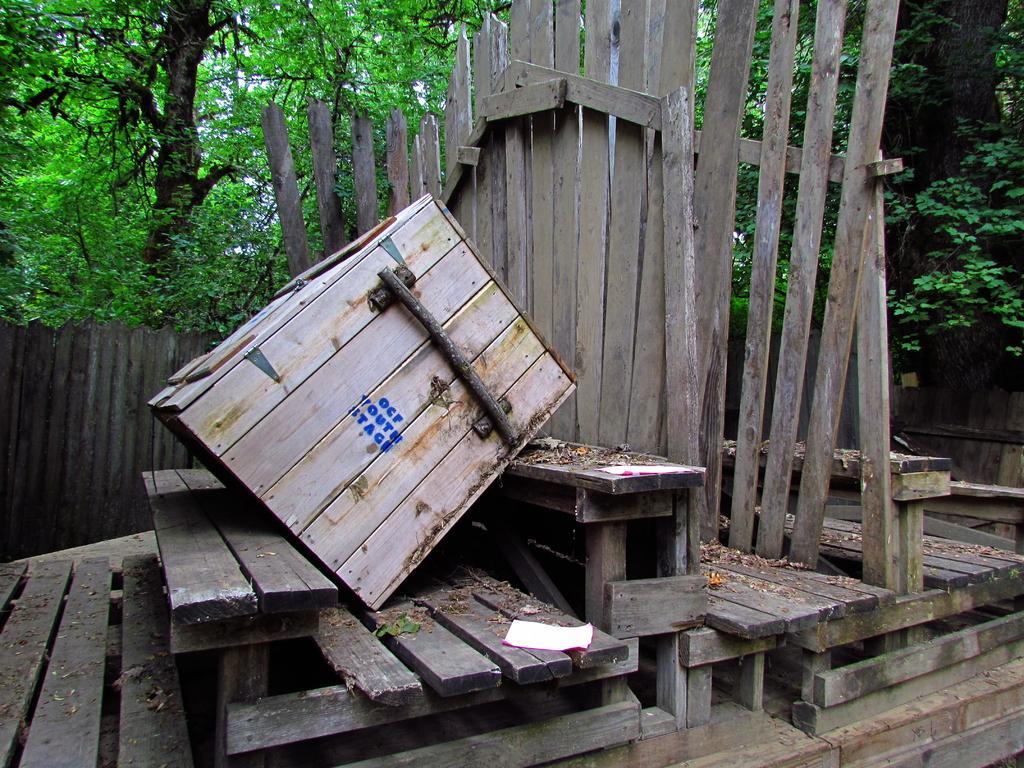In one or two sentences, can you explain what this image depicts? In this picture we can see papers, wooden objects, wooden fence and in the background we can see trees. 